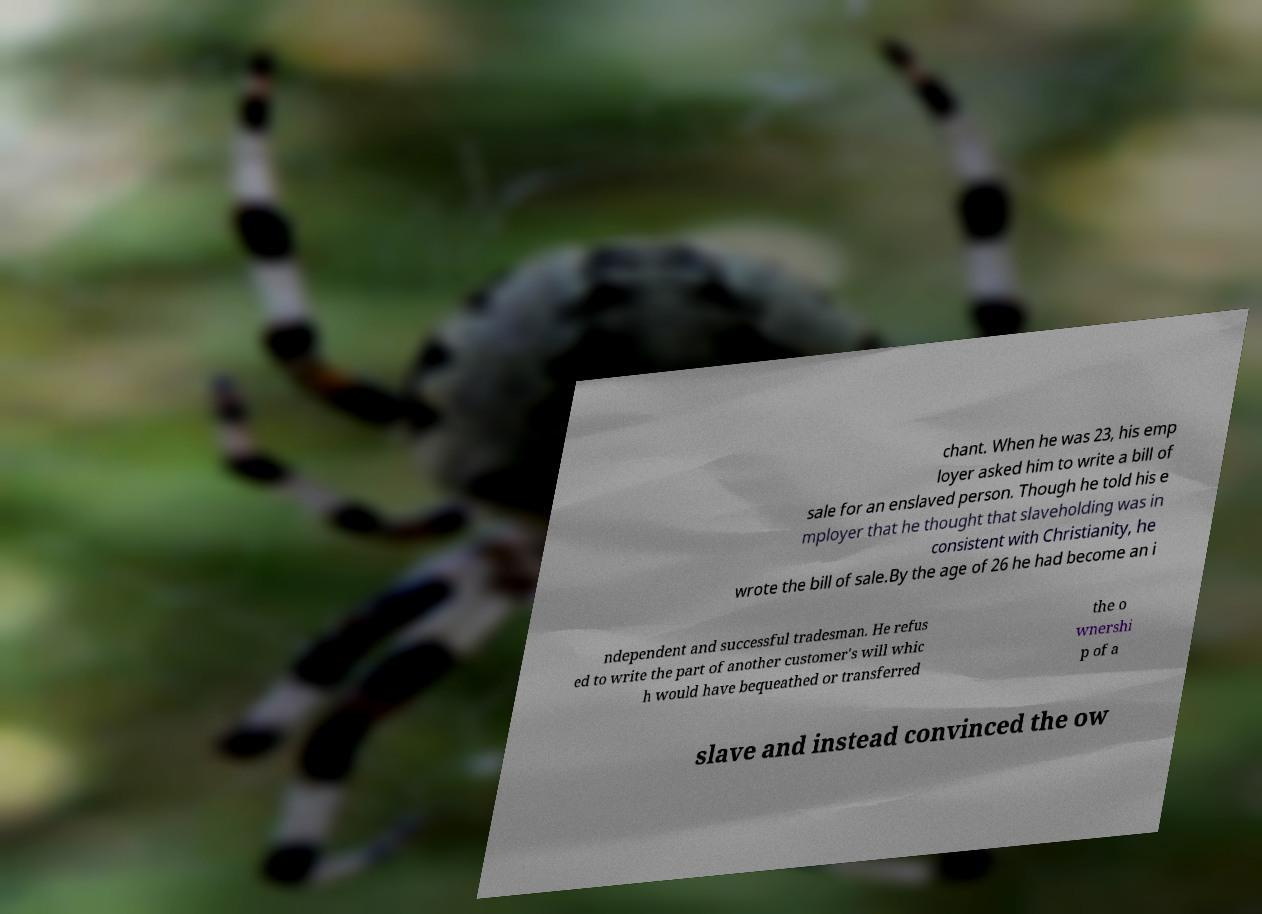Can you accurately transcribe the text from the provided image for me? chant. When he was 23, his emp loyer asked him to write a bill of sale for an enslaved person. Though he told his e mployer that he thought that slaveholding was in consistent with Christianity, he wrote the bill of sale.By the age of 26 he had become an i ndependent and successful tradesman. He refus ed to write the part of another customer's will whic h would have bequeathed or transferred the o wnershi p of a slave and instead convinced the ow 